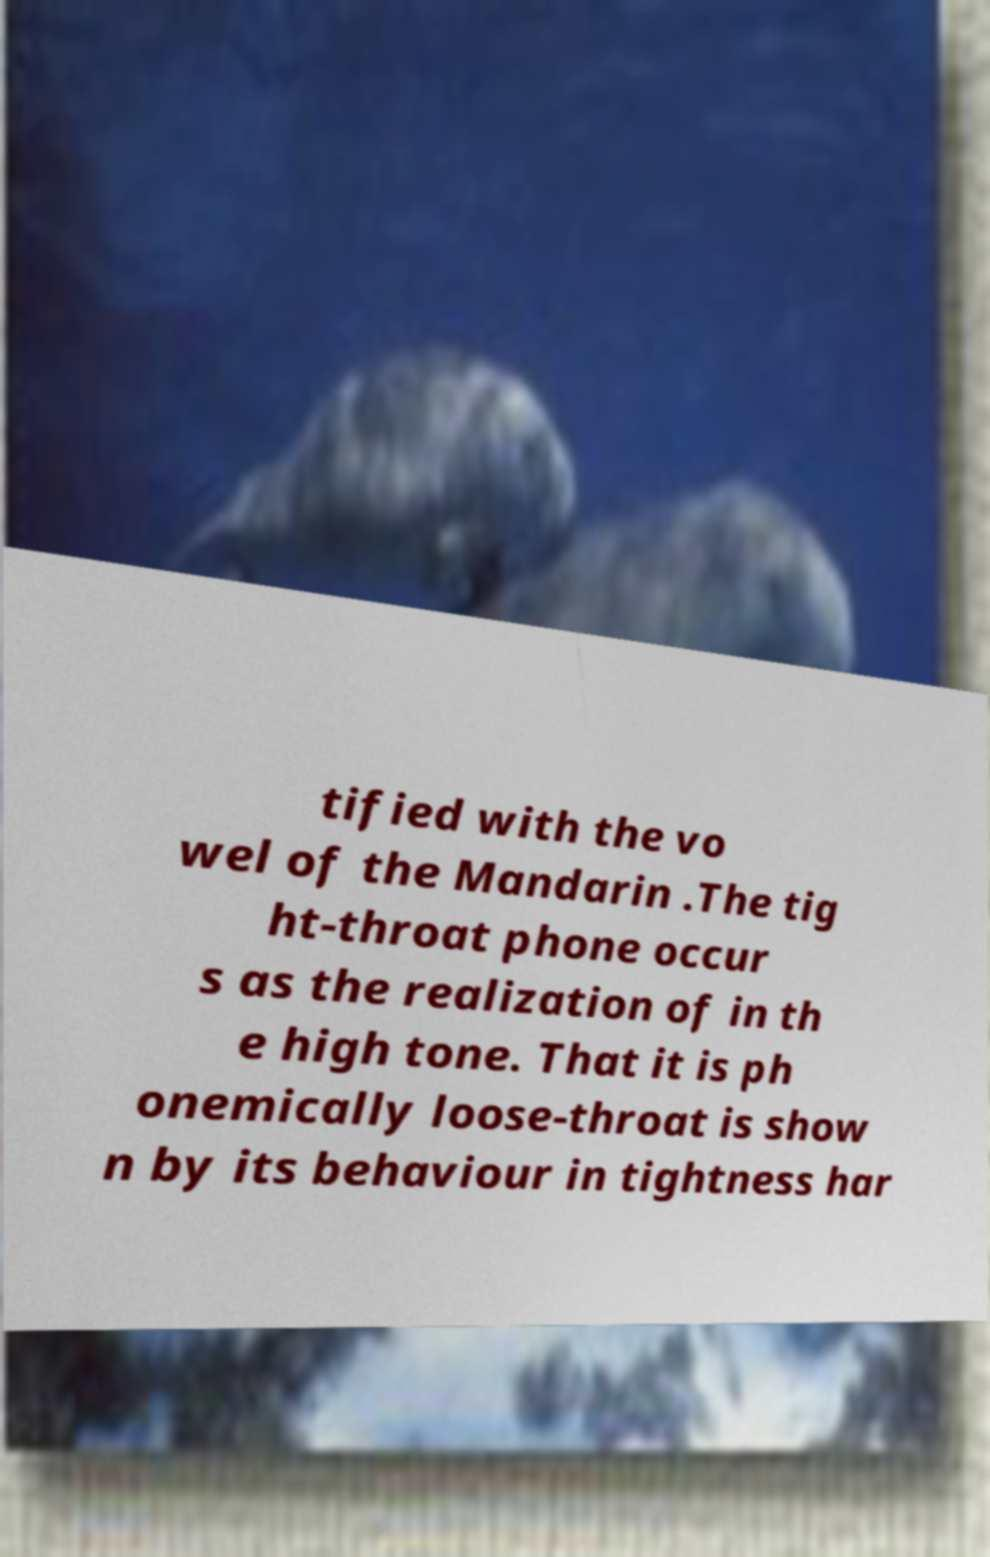I need the written content from this picture converted into text. Can you do that? tified with the vo wel of the Mandarin .The tig ht-throat phone occur s as the realization of in th e high tone. That it is ph onemically loose-throat is show n by its behaviour in tightness har 